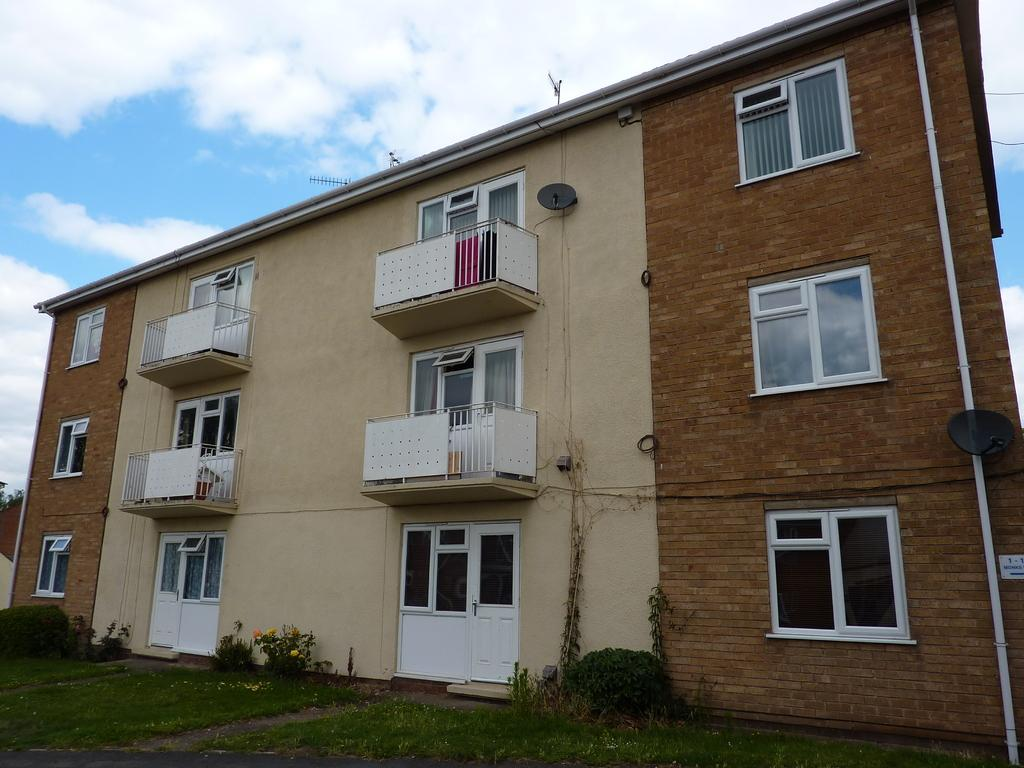What type of structure is visible in the image? There is a building in the image. What can be seen attached to the building? There are grills, windows, an antenna, and a pipeline visible in the image. Are there any natural elements present in the image? Yes, there are creepers and plants in the image. What is visible in the background of the image? The sky is visible in the background of the image, with clouds present. How many clocks are hanging on the walls of the building in the image? There is no information about clocks in the image, so we cannot determine their presence or quantity. 